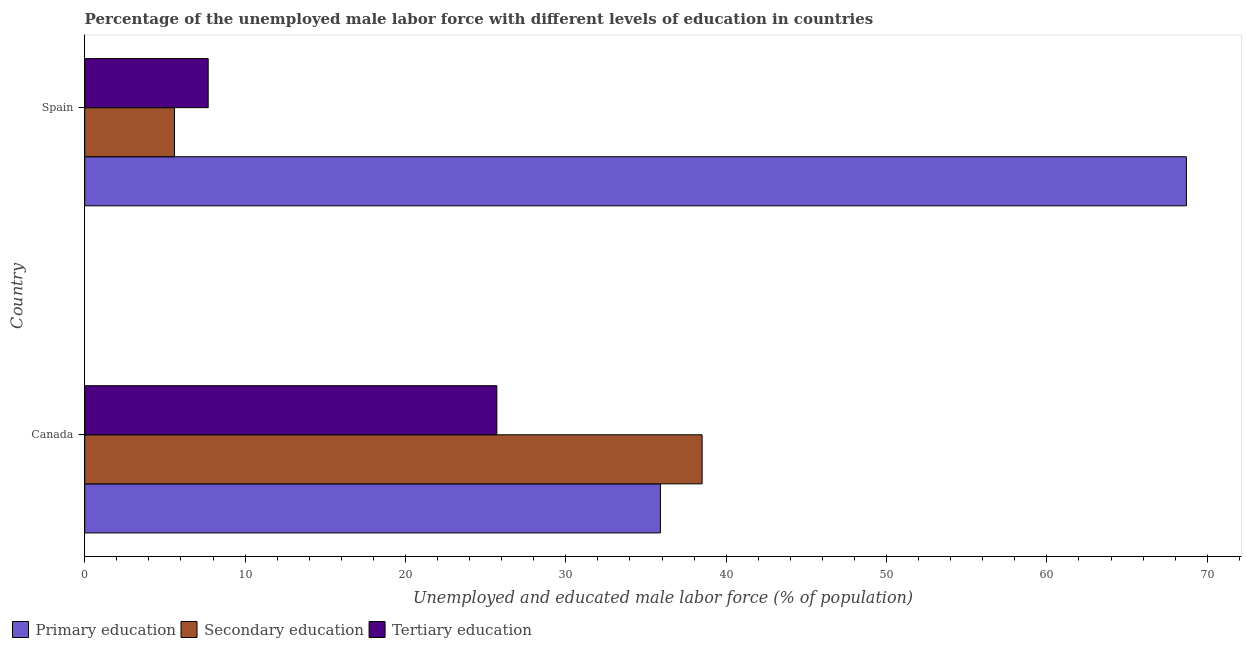How many different coloured bars are there?
Keep it short and to the point. 3. How many groups of bars are there?
Offer a terse response. 2. Are the number of bars on each tick of the Y-axis equal?
Offer a very short reply. Yes. How many bars are there on the 2nd tick from the top?
Provide a short and direct response. 3. In how many cases, is the number of bars for a given country not equal to the number of legend labels?
Provide a succinct answer. 0. What is the percentage of male labor force who received tertiary education in Canada?
Offer a terse response. 25.7. Across all countries, what is the maximum percentage of male labor force who received tertiary education?
Your answer should be very brief. 25.7. Across all countries, what is the minimum percentage of male labor force who received secondary education?
Your answer should be very brief. 5.6. In which country was the percentage of male labor force who received primary education maximum?
Provide a short and direct response. Spain. What is the total percentage of male labor force who received tertiary education in the graph?
Provide a short and direct response. 33.4. What is the difference between the percentage of male labor force who received primary education in Canada and that in Spain?
Offer a very short reply. -32.8. What is the difference between the percentage of male labor force who received tertiary education in Canada and the percentage of male labor force who received secondary education in Spain?
Ensure brevity in your answer.  20.1. What is the average percentage of male labor force who received tertiary education per country?
Offer a very short reply. 16.7. What is the difference between the percentage of male labor force who received primary education and percentage of male labor force who received secondary education in Canada?
Give a very brief answer. -2.6. In how many countries, is the percentage of male labor force who received secondary education greater than 48 %?
Provide a succinct answer. 0. What is the ratio of the percentage of male labor force who received tertiary education in Canada to that in Spain?
Keep it short and to the point. 3.34. In how many countries, is the percentage of male labor force who received primary education greater than the average percentage of male labor force who received primary education taken over all countries?
Give a very brief answer. 1. What does the 2nd bar from the bottom in Canada represents?
Provide a succinct answer. Secondary education. Is it the case that in every country, the sum of the percentage of male labor force who received primary education and percentage of male labor force who received secondary education is greater than the percentage of male labor force who received tertiary education?
Offer a terse response. Yes. How many bars are there?
Ensure brevity in your answer.  6. How many countries are there in the graph?
Your response must be concise. 2. What is the difference between two consecutive major ticks on the X-axis?
Provide a short and direct response. 10. Does the graph contain any zero values?
Your response must be concise. No. How many legend labels are there?
Make the answer very short. 3. What is the title of the graph?
Your response must be concise. Percentage of the unemployed male labor force with different levels of education in countries. What is the label or title of the X-axis?
Make the answer very short. Unemployed and educated male labor force (% of population). What is the Unemployed and educated male labor force (% of population) in Primary education in Canada?
Provide a succinct answer. 35.9. What is the Unemployed and educated male labor force (% of population) of Secondary education in Canada?
Your answer should be very brief. 38.5. What is the Unemployed and educated male labor force (% of population) in Tertiary education in Canada?
Your answer should be very brief. 25.7. What is the Unemployed and educated male labor force (% of population) in Primary education in Spain?
Give a very brief answer. 68.7. What is the Unemployed and educated male labor force (% of population) in Secondary education in Spain?
Ensure brevity in your answer.  5.6. What is the Unemployed and educated male labor force (% of population) in Tertiary education in Spain?
Keep it short and to the point. 7.7. Across all countries, what is the maximum Unemployed and educated male labor force (% of population) of Primary education?
Your answer should be very brief. 68.7. Across all countries, what is the maximum Unemployed and educated male labor force (% of population) of Secondary education?
Provide a succinct answer. 38.5. Across all countries, what is the maximum Unemployed and educated male labor force (% of population) of Tertiary education?
Provide a succinct answer. 25.7. Across all countries, what is the minimum Unemployed and educated male labor force (% of population) in Primary education?
Offer a very short reply. 35.9. Across all countries, what is the minimum Unemployed and educated male labor force (% of population) in Secondary education?
Your response must be concise. 5.6. Across all countries, what is the minimum Unemployed and educated male labor force (% of population) in Tertiary education?
Provide a succinct answer. 7.7. What is the total Unemployed and educated male labor force (% of population) of Primary education in the graph?
Ensure brevity in your answer.  104.6. What is the total Unemployed and educated male labor force (% of population) of Secondary education in the graph?
Your answer should be compact. 44.1. What is the total Unemployed and educated male labor force (% of population) in Tertiary education in the graph?
Provide a succinct answer. 33.4. What is the difference between the Unemployed and educated male labor force (% of population) of Primary education in Canada and that in Spain?
Your answer should be compact. -32.8. What is the difference between the Unemployed and educated male labor force (% of population) in Secondary education in Canada and that in Spain?
Give a very brief answer. 32.9. What is the difference between the Unemployed and educated male labor force (% of population) in Tertiary education in Canada and that in Spain?
Ensure brevity in your answer.  18. What is the difference between the Unemployed and educated male labor force (% of population) of Primary education in Canada and the Unemployed and educated male labor force (% of population) of Secondary education in Spain?
Your answer should be compact. 30.3. What is the difference between the Unemployed and educated male labor force (% of population) of Primary education in Canada and the Unemployed and educated male labor force (% of population) of Tertiary education in Spain?
Your answer should be very brief. 28.2. What is the difference between the Unemployed and educated male labor force (% of population) of Secondary education in Canada and the Unemployed and educated male labor force (% of population) of Tertiary education in Spain?
Give a very brief answer. 30.8. What is the average Unemployed and educated male labor force (% of population) in Primary education per country?
Provide a short and direct response. 52.3. What is the average Unemployed and educated male labor force (% of population) of Secondary education per country?
Provide a short and direct response. 22.05. What is the average Unemployed and educated male labor force (% of population) in Tertiary education per country?
Make the answer very short. 16.7. What is the difference between the Unemployed and educated male labor force (% of population) of Primary education and Unemployed and educated male labor force (% of population) of Secondary education in Canada?
Provide a succinct answer. -2.6. What is the difference between the Unemployed and educated male labor force (% of population) of Primary education and Unemployed and educated male labor force (% of population) of Secondary education in Spain?
Keep it short and to the point. 63.1. What is the difference between the Unemployed and educated male labor force (% of population) in Primary education and Unemployed and educated male labor force (% of population) in Tertiary education in Spain?
Give a very brief answer. 61. What is the ratio of the Unemployed and educated male labor force (% of population) of Primary education in Canada to that in Spain?
Offer a very short reply. 0.52. What is the ratio of the Unemployed and educated male labor force (% of population) in Secondary education in Canada to that in Spain?
Provide a short and direct response. 6.88. What is the ratio of the Unemployed and educated male labor force (% of population) of Tertiary education in Canada to that in Spain?
Offer a very short reply. 3.34. What is the difference between the highest and the second highest Unemployed and educated male labor force (% of population) in Primary education?
Your response must be concise. 32.8. What is the difference between the highest and the second highest Unemployed and educated male labor force (% of population) in Secondary education?
Offer a very short reply. 32.9. What is the difference between the highest and the lowest Unemployed and educated male labor force (% of population) in Primary education?
Give a very brief answer. 32.8. What is the difference between the highest and the lowest Unemployed and educated male labor force (% of population) of Secondary education?
Provide a succinct answer. 32.9. 